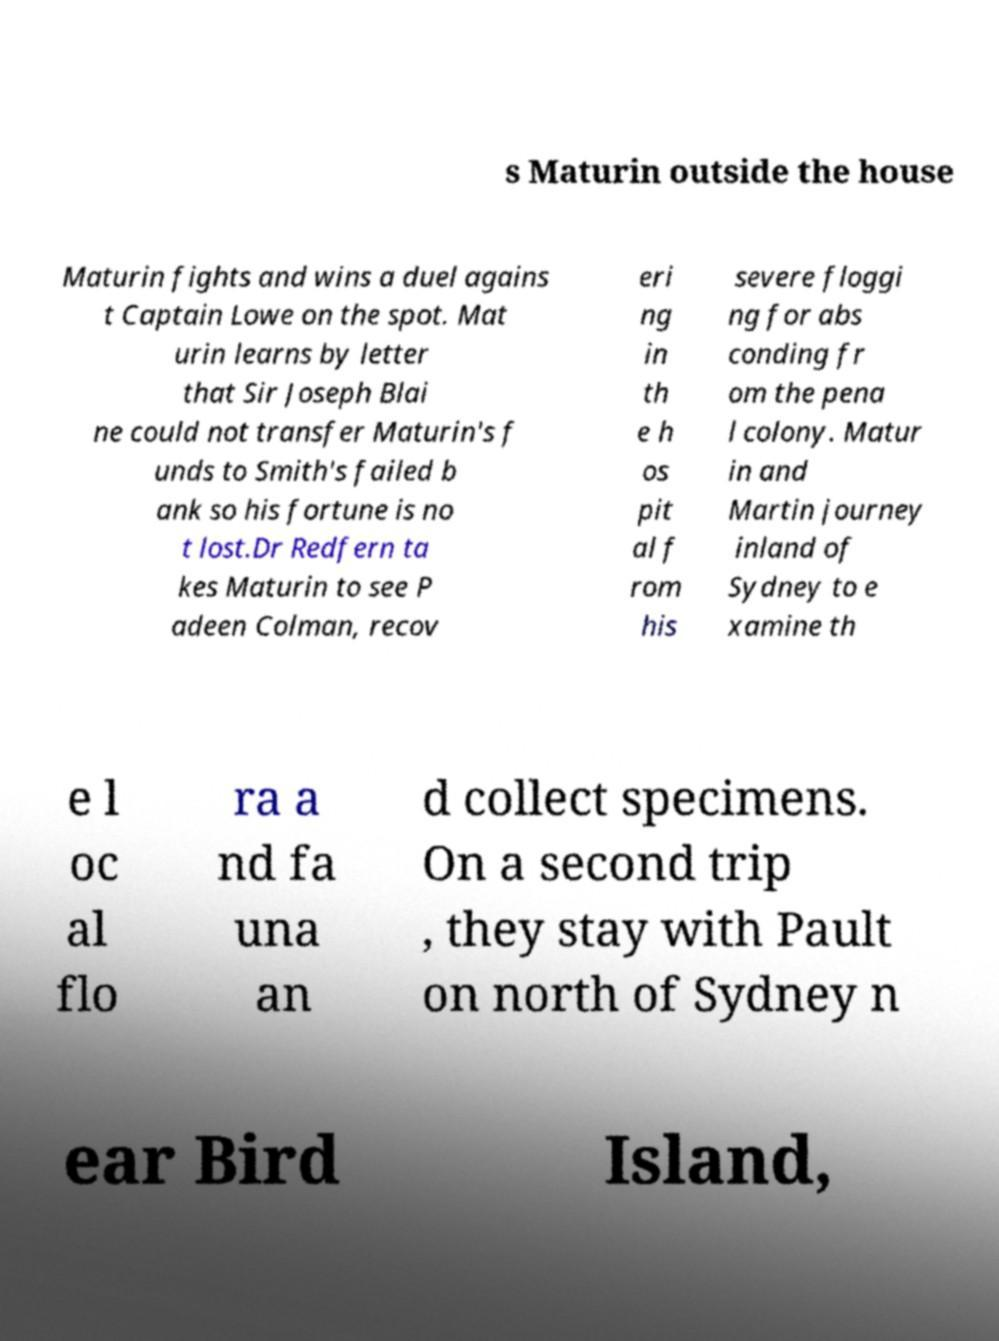There's text embedded in this image that I need extracted. Can you transcribe it verbatim? s Maturin outside the house Maturin fights and wins a duel agains t Captain Lowe on the spot. Mat urin learns by letter that Sir Joseph Blai ne could not transfer Maturin's f unds to Smith's failed b ank so his fortune is no t lost.Dr Redfern ta kes Maturin to see P adeen Colman, recov eri ng in th e h os pit al f rom his severe floggi ng for abs conding fr om the pena l colony. Matur in and Martin journey inland of Sydney to e xamine th e l oc al flo ra a nd fa una an d collect specimens. On a second trip , they stay with Pault on north of Sydney n ear Bird Island, 